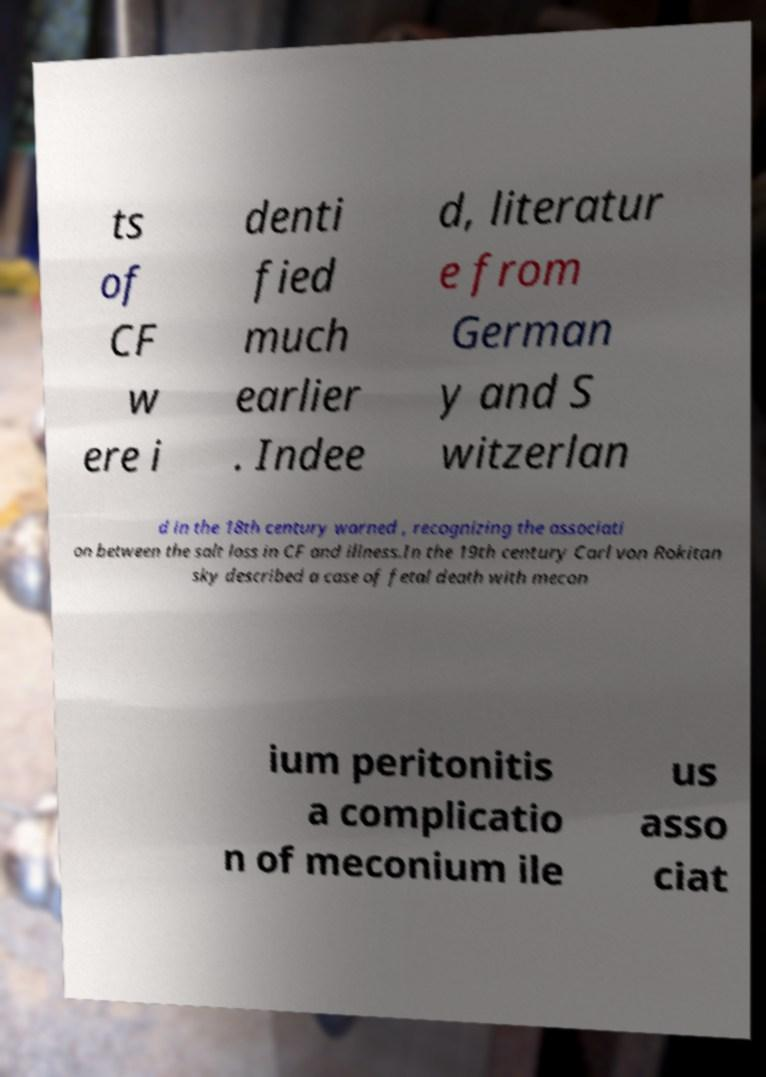Please identify and transcribe the text found in this image. ts of CF w ere i denti fied much earlier . Indee d, literatur e from German y and S witzerlan d in the 18th century warned , recognizing the associati on between the salt loss in CF and illness.In the 19th century Carl von Rokitan sky described a case of fetal death with mecon ium peritonitis a complicatio n of meconium ile us asso ciat 